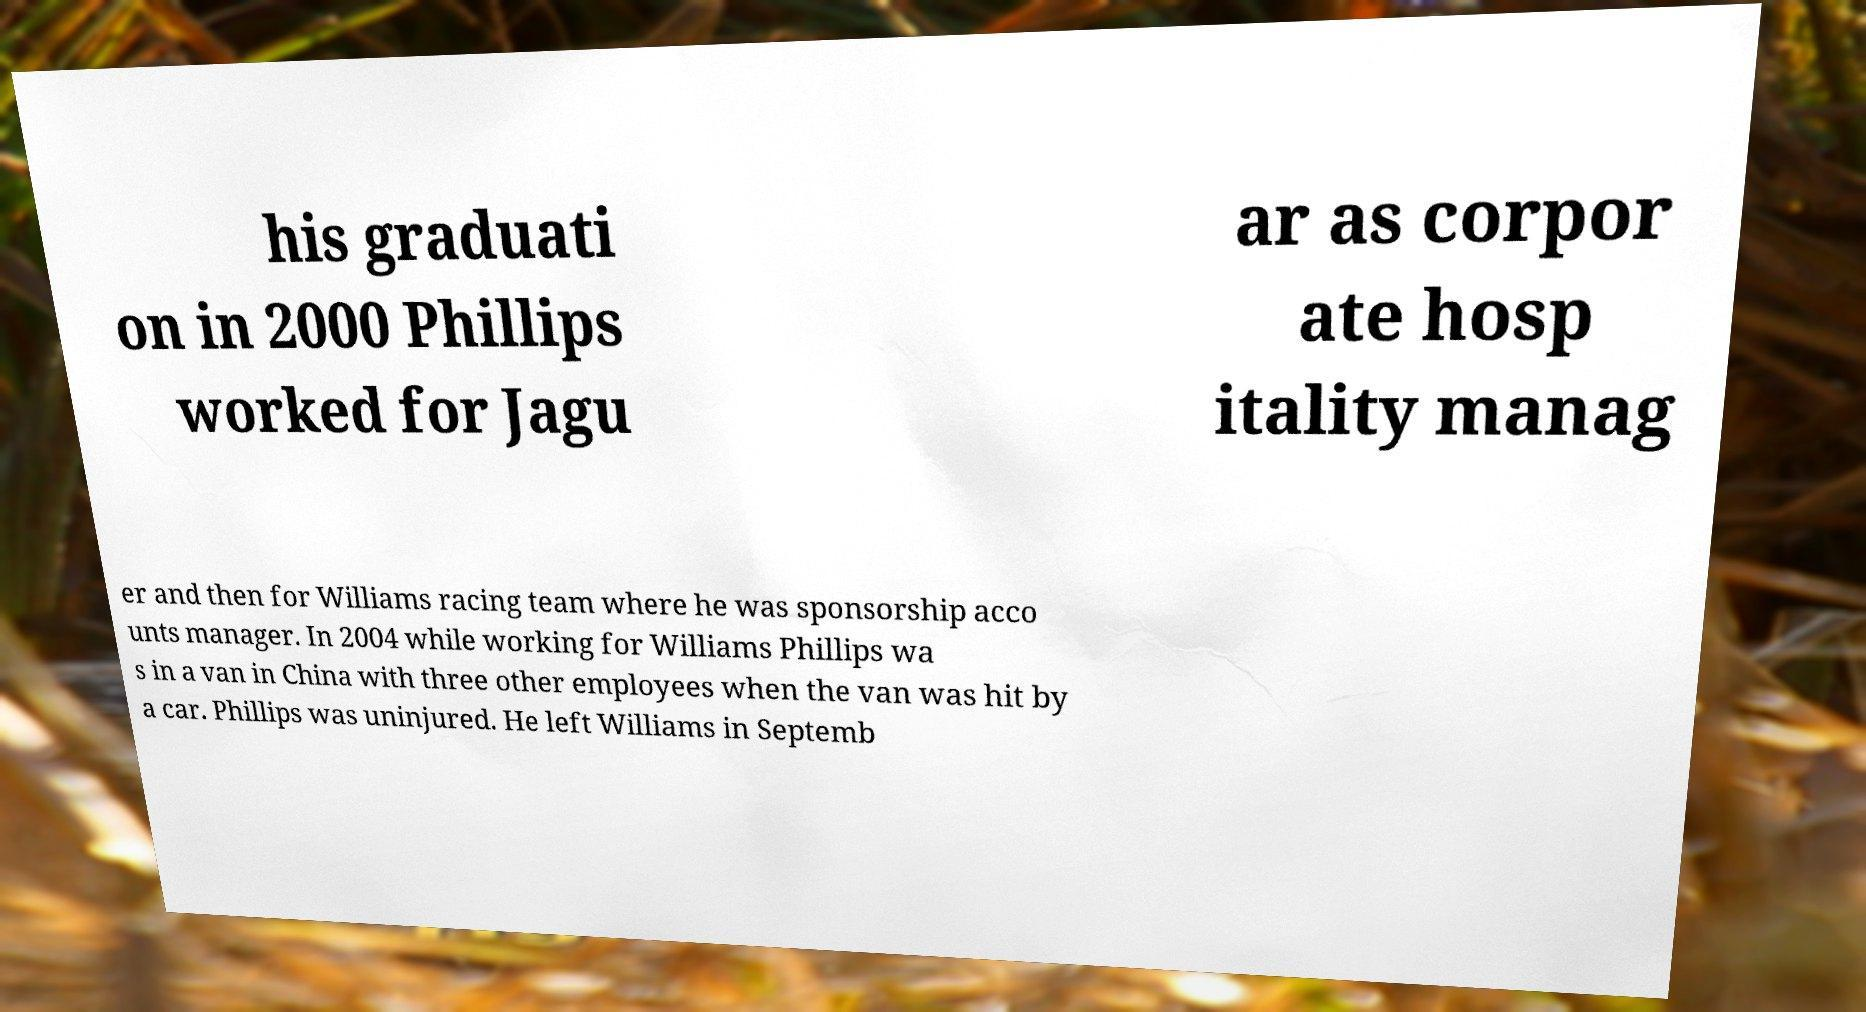Please identify and transcribe the text found in this image. his graduati on in 2000 Phillips worked for Jagu ar as corpor ate hosp itality manag er and then for Williams racing team where he was sponsorship acco unts manager. In 2004 while working for Williams Phillips wa s in a van in China with three other employees when the van was hit by a car. Phillips was uninjured. He left Williams in Septemb 